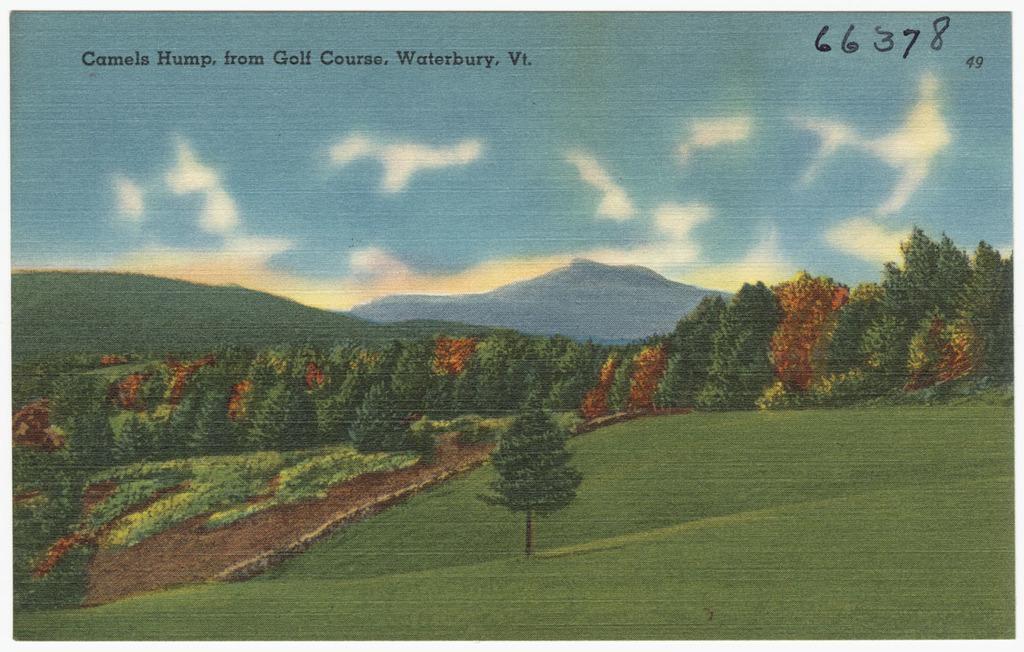Please provide a concise description of this image. In this image there is a poster where there are few trees, grass, mountains, some clouds in the sky and some text at the top of the poster. 